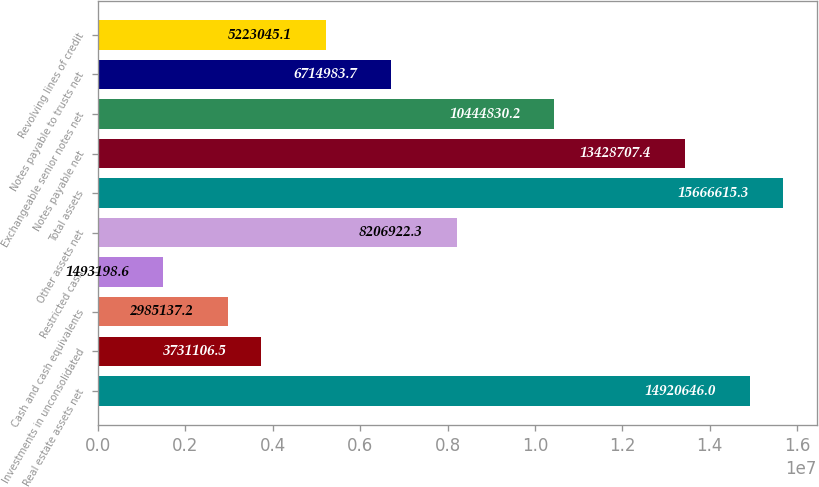Convert chart. <chart><loc_0><loc_0><loc_500><loc_500><bar_chart><fcel>Real estate assets net<fcel>Investments in unconsolidated<fcel>Cash and cash equivalents<fcel>Restricted cash<fcel>Other assets net<fcel>Total assets<fcel>Notes payable net<fcel>Exchangeable senior notes net<fcel>Notes payable to trusts net<fcel>Revolving lines of credit<nl><fcel>1.49206e+07<fcel>3.73111e+06<fcel>2.98514e+06<fcel>1.4932e+06<fcel>8.20692e+06<fcel>1.56666e+07<fcel>1.34287e+07<fcel>1.04448e+07<fcel>6.71498e+06<fcel>5.22305e+06<nl></chart> 